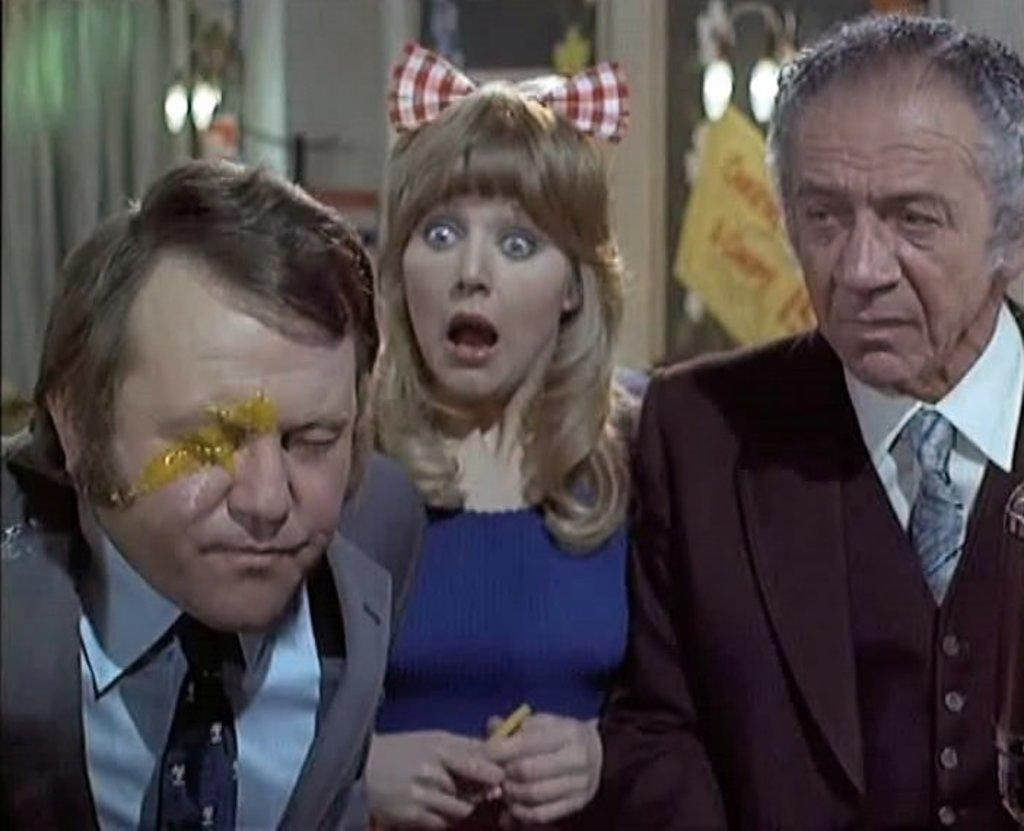How many people are present in the image? There are three people in the image. What can be observed about the clothing of the people in the image? The people are wearing different color dresses. What can be seen in the background of the image? There is a curtain and a wall in the background of the image. How would you describe the background of the image? The background of the image is blurry. Where is the throne located in the image? There is no throne present in the image. Can you describe the ocean in the image? There is no ocean present in the image. 